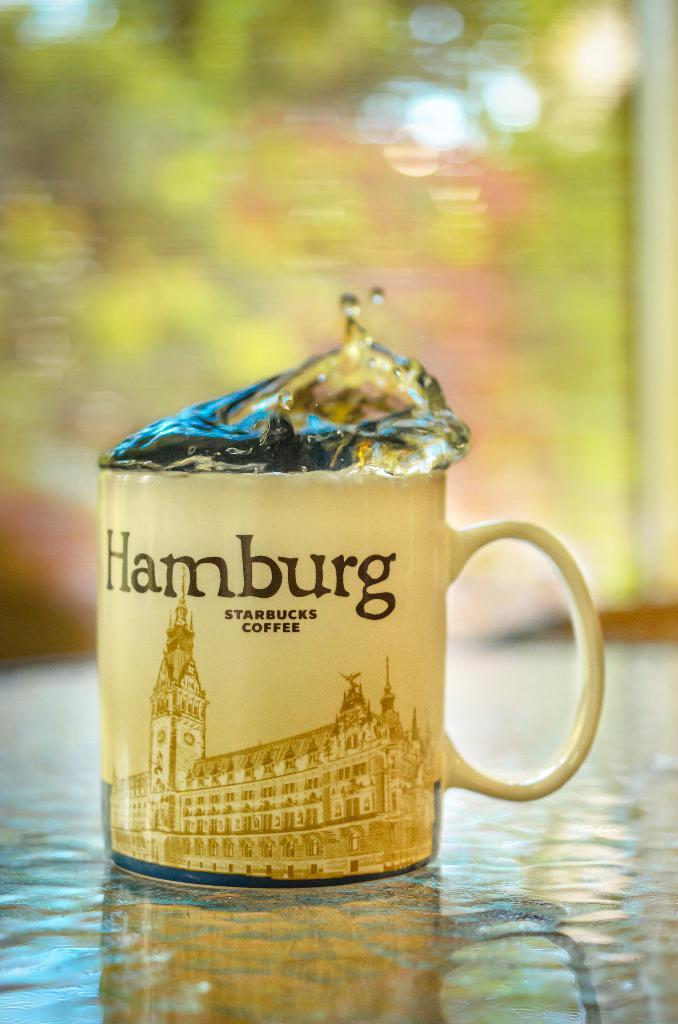<image>
Render a clear and concise summary of the photo. a coffee mug that says Hamburg sits on the table. 